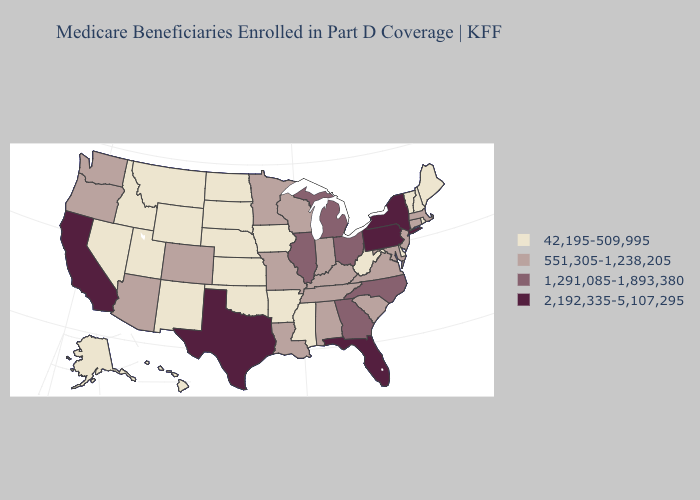Name the states that have a value in the range 42,195-509,995?
Be succinct. Alaska, Arkansas, Delaware, Hawaii, Idaho, Iowa, Kansas, Maine, Mississippi, Montana, Nebraska, Nevada, New Hampshire, New Mexico, North Dakota, Oklahoma, Rhode Island, South Dakota, Utah, Vermont, West Virginia, Wyoming. What is the highest value in the South ?
Quick response, please. 2,192,335-5,107,295. Name the states that have a value in the range 2,192,335-5,107,295?
Give a very brief answer. California, Florida, New York, Pennsylvania, Texas. Is the legend a continuous bar?
Quick response, please. No. Does the map have missing data?
Write a very short answer. No. What is the value of New Jersey?
Write a very short answer. 551,305-1,238,205. What is the lowest value in the USA?
Give a very brief answer. 42,195-509,995. What is the value of Texas?
Concise answer only. 2,192,335-5,107,295. Name the states that have a value in the range 551,305-1,238,205?
Quick response, please. Alabama, Arizona, Colorado, Connecticut, Indiana, Kentucky, Louisiana, Maryland, Massachusetts, Minnesota, Missouri, New Jersey, Oregon, South Carolina, Tennessee, Virginia, Washington, Wisconsin. Is the legend a continuous bar?
Answer briefly. No. Name the states that have a value in the range 42,195-509,995?
Concise answer only. Alaska, Arkansas, Delaware, Hawaii, Idaho, Iowa, Kansas, Maine, Mississippi, Montana, Nebraska, Nevada, New Hampshire, New Mexico, North Dakota, Oklahoma, Rhode Island, South Dakota, Utah, Vermont, West Virginia, Wyoming. What is the highest value in the South ?
Give a very brief answer. 2,192,335-5,107,295. What is the value of Wisconsin?
Write a very short answer. 551,305-1,238,205. Among the states that border Utah , does Colorado have the highest value?
Quick response, please. Yes. Among the states that border South Carolina , which have the lowest value?
Answer briefly. Georgia, North Carolina. 